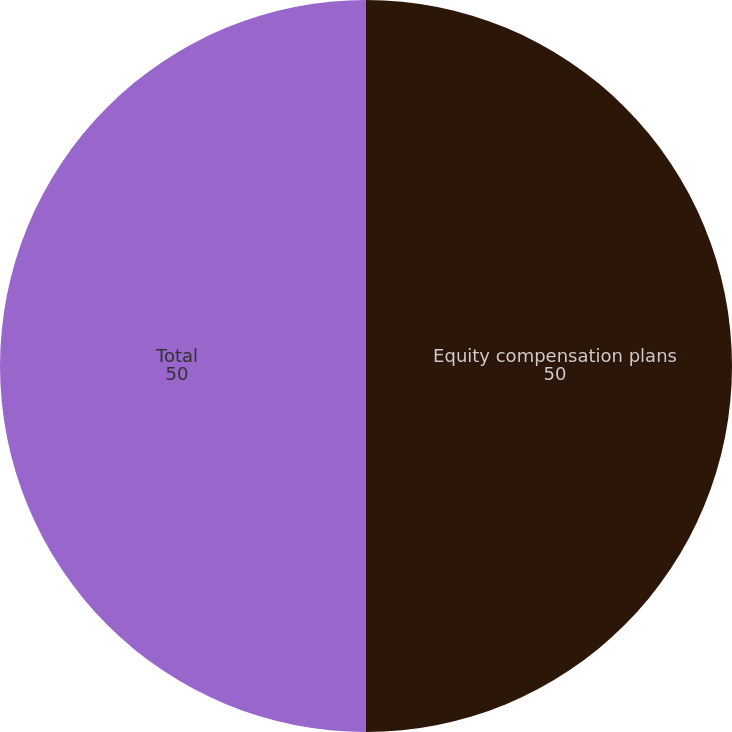<chart> <loc_0><loc_0><loc_500><loc_500><pie_chart><fcel>Equity compensation plans<fcel>Total<nl><fcel>50.0%<fcel>50.0%<nl></chart> 